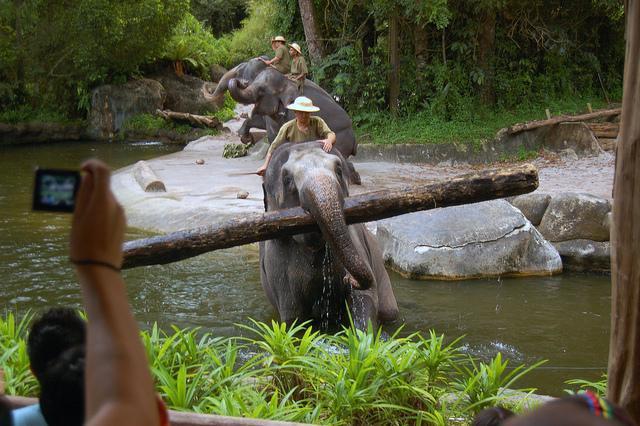How many elephants are there?
Give a very brief answer. 2. How many people are in the photo?
Give a very brief answer. 2. 